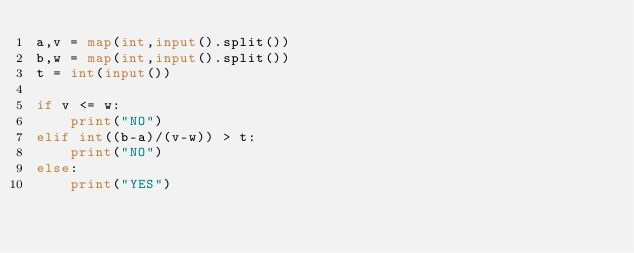<code> <loc_0><loc_0><loc_500><loc_500><_Python_>a,v = map(int,input().split())
b,w = map(int,input().split())
t = int(input())

if v <= w:
    print("NO")
elif int((b-a)/(v-w)) > t:
    print("NO") 
else:
    print("YES")</code> 